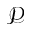<formula> <loc_0><loc_0><loc_500><loc_500>\mathcal { P }</formula> 